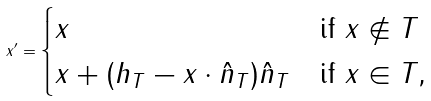Convert formula to latex. <formula><loc_0><loc_0><loc_500><loc_500>x ^ { \prime } = \begin{cases} x & \text {if $x\not\in T$ } \\ x + ( h _ { T } - x \cdot \hat { n } _ { T } ) \hat { n } _ { T } & \text {if $x\in T$, } \end{cases}</formula> 